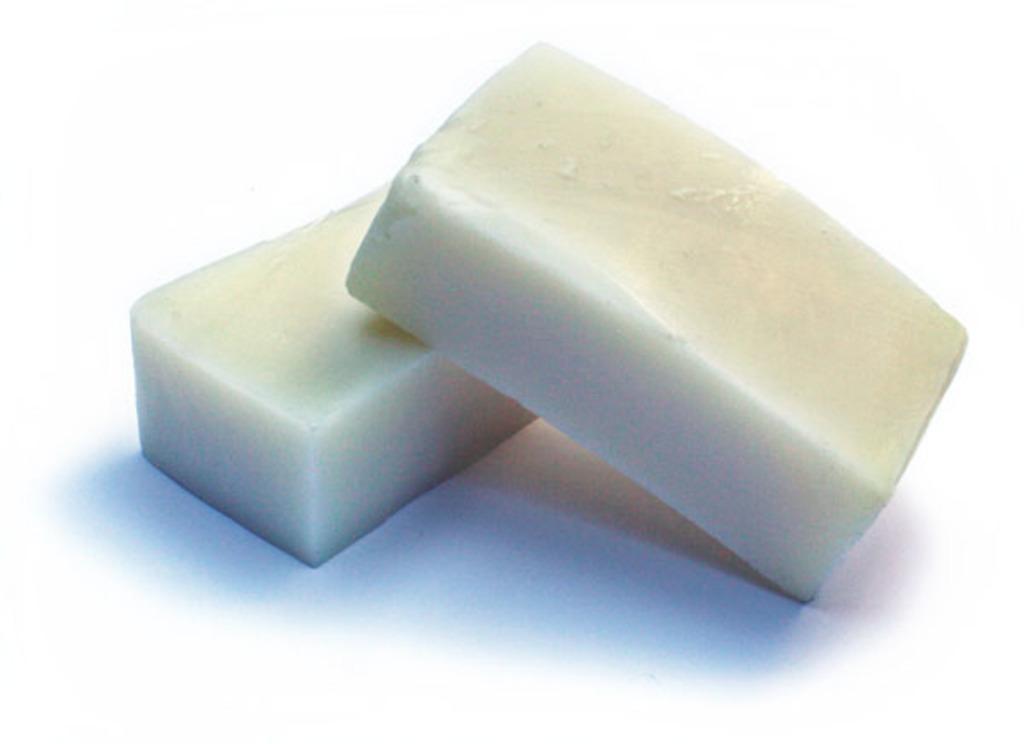How would you summarize this image in a sentence or two? In this picture, we can see some white color objects. 